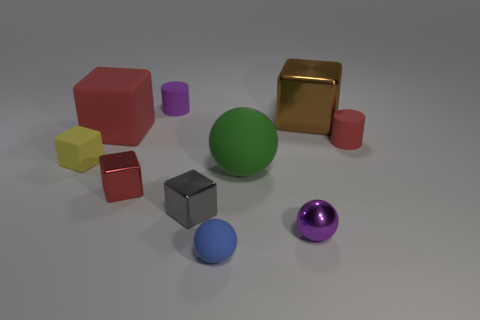Subtract all small gray metal blocks. How many blocks are left? 4 Subtract 2 cubes. How many cubes are left? 3 Subtract all brown blocks. How many blocks are left? 4 Subtract all cyan blocks. Subtract all brown cylinders. How many blocks are left? 5 Subtract all cylinders. How many objects are left? 8 Add 6 big brown things. How many big brown things exist? 7 Subtract 0 brown balls. How many objects are left? 10 Subtract all purple spheres. Subtract all tiny yellow rubber blocks. How many objects are left? 8 Add 7 green matte spheres. How many green matte spheres are left? 8 